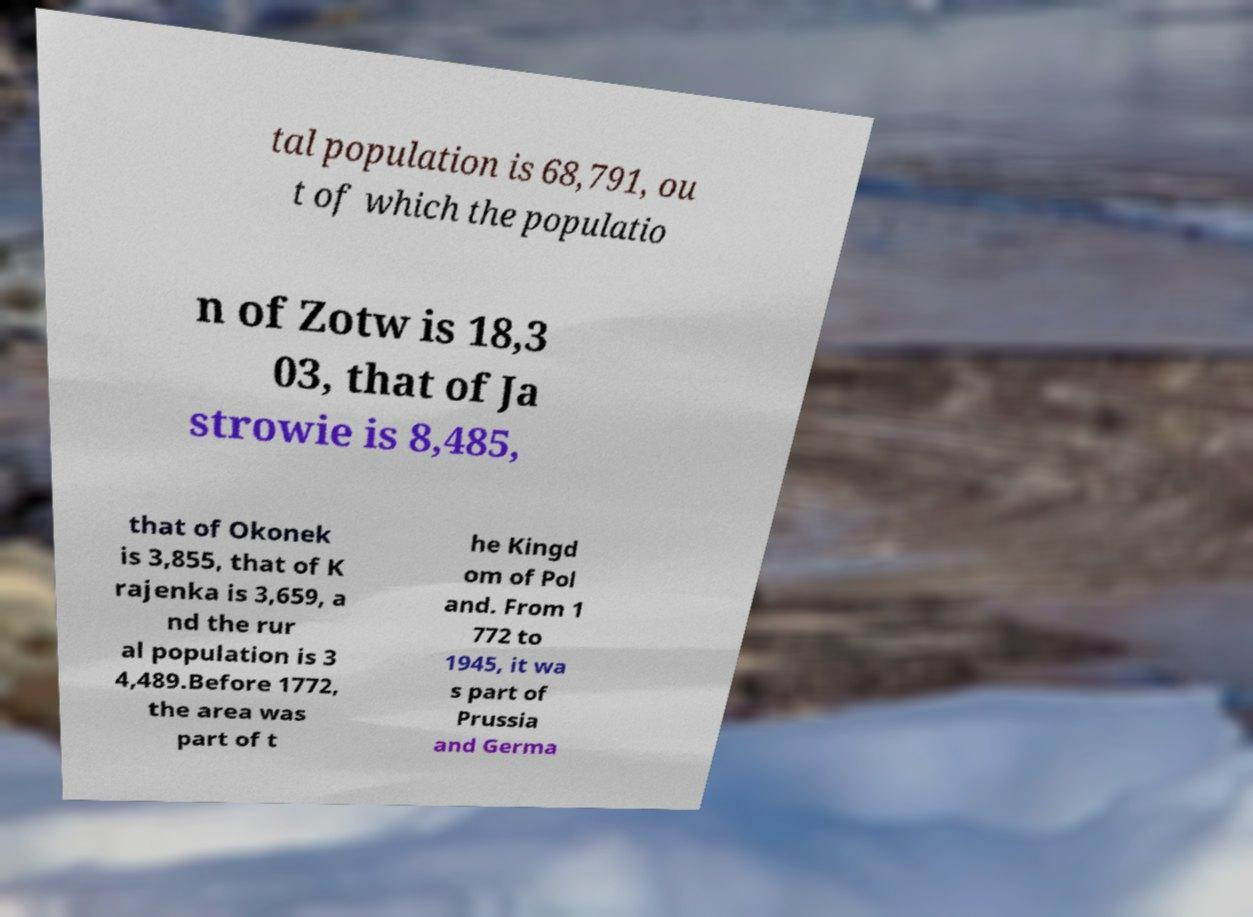Please read and relay the text visible in this image. What does it say? tal population is 68,791, ou t of which the populatio n of Zotw is 18,3 03, that of Ja strowie is 8,485, that of Okonek is 3,855, that of K rajenka is 3,659, a nd the rur al population is 3 4,489.Before 1772, the area was part of t he Kingd om of Pol and. From 1 772 to 1945, it wa s part of Prussia and Germa 